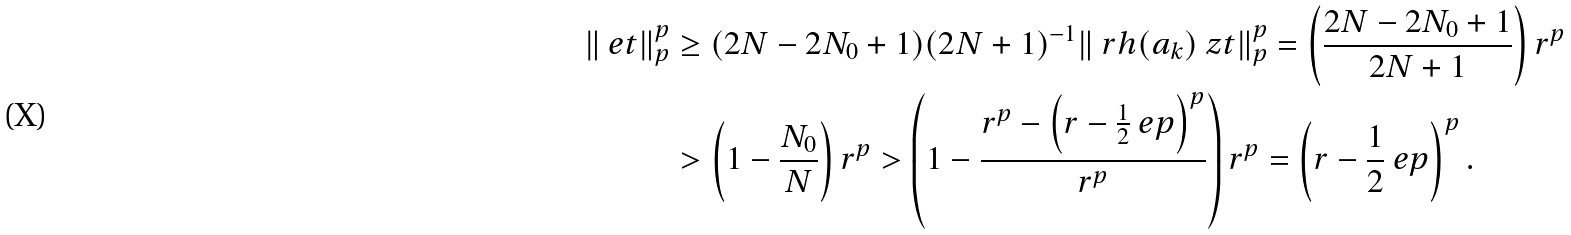Convert formula to latex. <formula><loc_0><loc_0><loc_500><loc_500>\| \ e t \| _ { p } ^ { p } & \geq ( 2 N - 2 N _ { 0 } + 1 ) ( 2 N + 1 ) ^ { - 1 } \| \ r h ( a _ { k } ) \ z t \| _ { p } ^ { p } = \left ( \frac { 2 N - 2 N _ { 0 } + 1 } { 2 N + 1 } \right ) r ^ { p } \\ & > \left ( 1 - \frac { N _ { 0 } } { N } \right ) r ^ { p } > \left ( 1 - \frac { r ^ { p } - \left ( r - \frac { 1 } { 2 } \ e p \right ) ^ { p } } { r ^ { p } } \right ) r ^ { p } = \left ( r - \frac { 1 } { 2 } \ e p \right ) ^ { p } .</formula> 